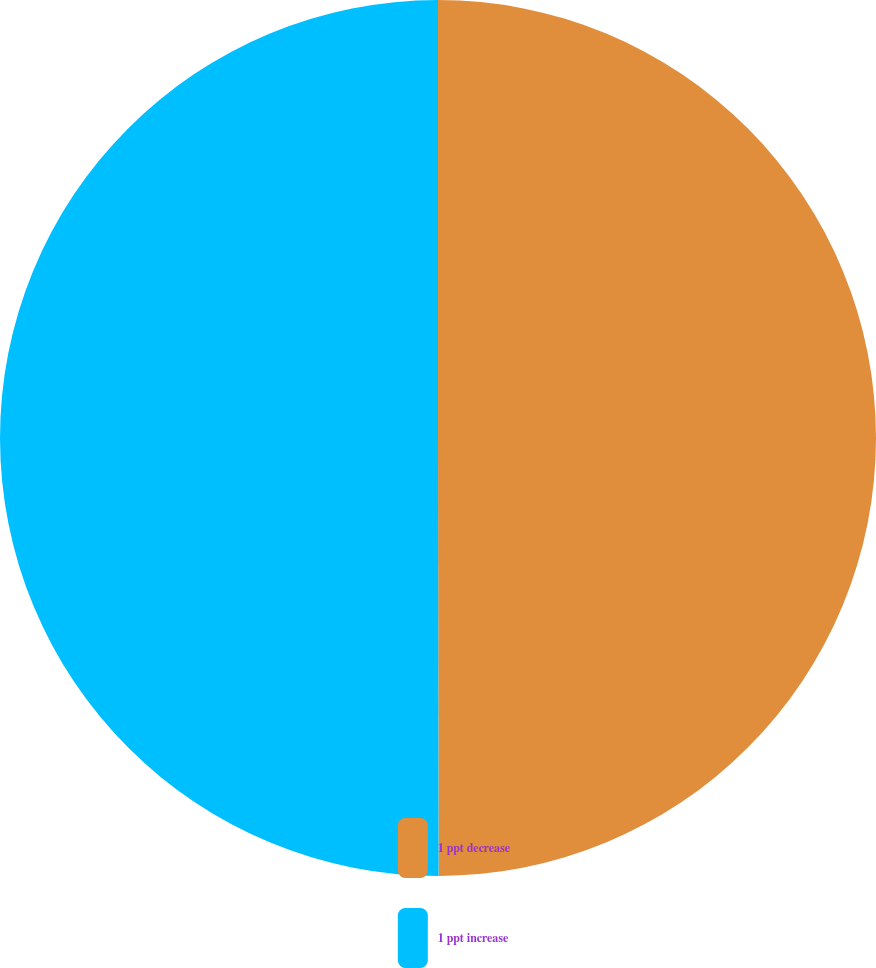Convert chart. <chart><loc_0><loc_0><loc_500><loc_500><pie_chart><fcel>1 ppt decrease<fcel>1 ppt increase<nl><fcel>49.98%<fcel>50.02%<nl></chart> 